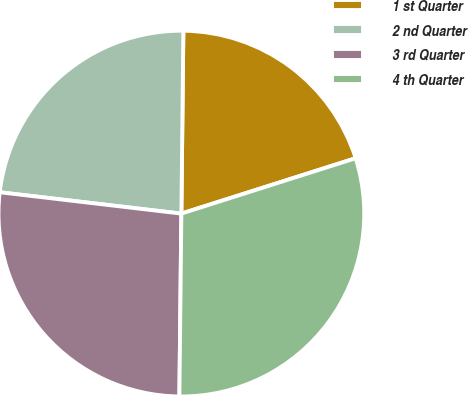Convert chart. <chart><loc_0><loc_0><loc_500><loc_500><pie_chart><fcel>1 st Quarter<fcel>2 nd Quarter<fcel>3 rd Quarter<fcel>4 th Quarter<nl><fcel>19.93%<fcel>23.31%<fcel>26.69%<fcel>30.07%<nl></chart> 